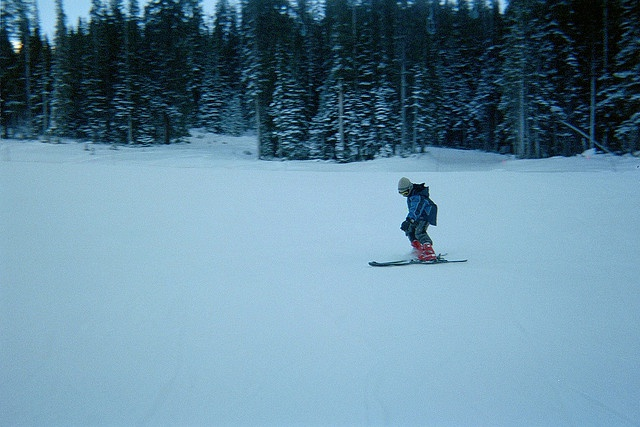Describe the objects in this image and their specific colors. I can see people in darkgray, navy, black, blue, and gray tones and skis in darkgray, blue, darkblue, teal, and black tones in this image. 